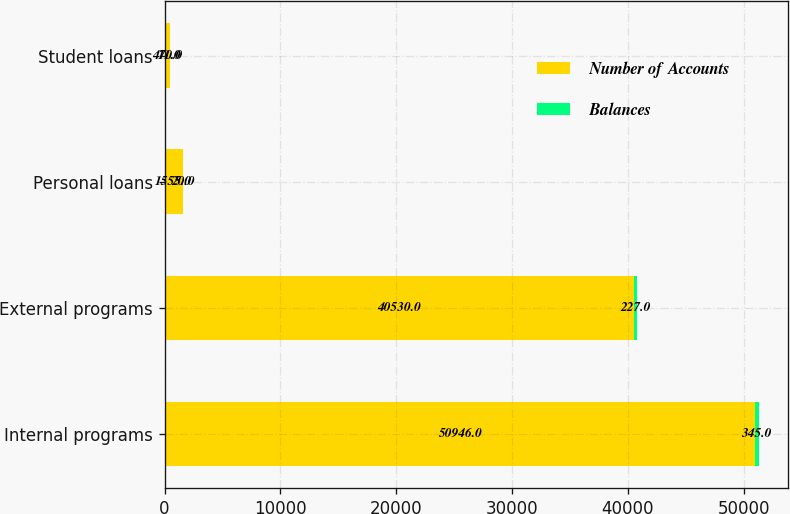<chart> <loc_0><loc_0><loc_500><loc_500><stacked_bar_chart><ecel><fcel>Internal programs<fcel>External programs<fcel>Personal loans<fcel>Student loans<nl><fcel>Number of Accounts<fcel>50946<fcel>40530<fcel>1555<fcel>470<nl><fcel>Balances<fcel>345<fcel>227<fcel>20<fcel>11<nl></chart> 